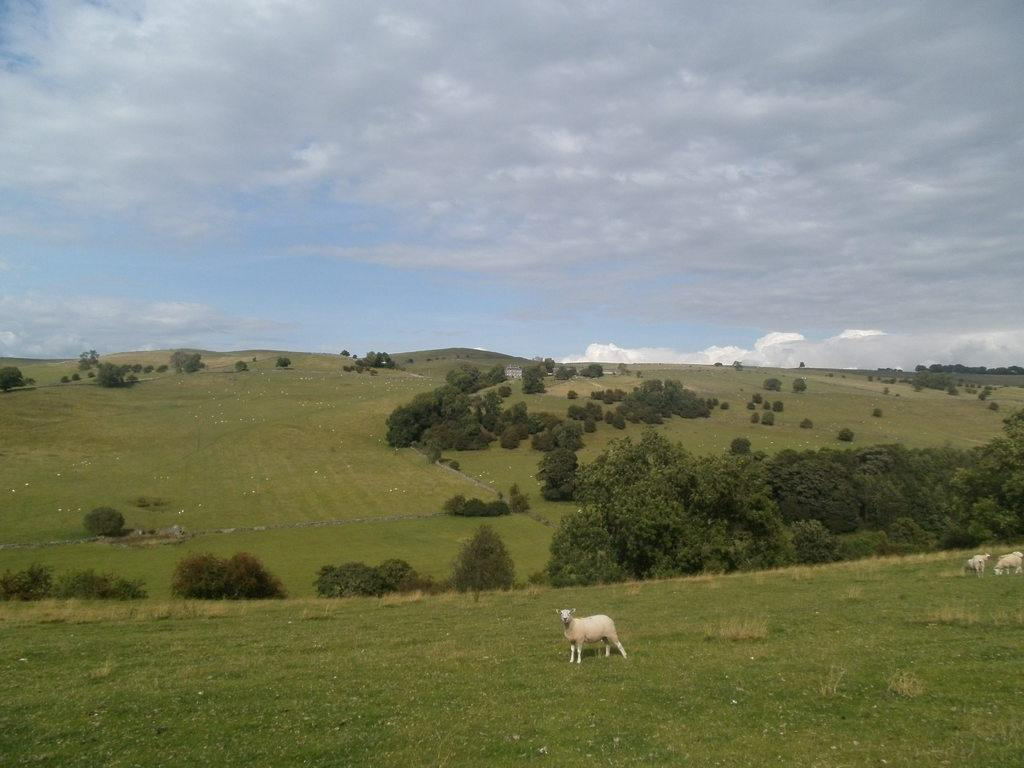What can be seen in the foreground of the picture? In the foreground of the picture, there are sheep, shrubs, and grass. What is located in the center of the picture? In the center of the picture, there are trees, hills, grass, and a field. How would you describe the sky in the picture? The sky in the picture is cloudy. What type of bed can be seen in the center of the picture? There is no bed present in the image; it features a field with trees, hills, and grass. What color is the ray in the center of the picture? There is no ray present in the image; it features a field with trees, hills, and grass. 